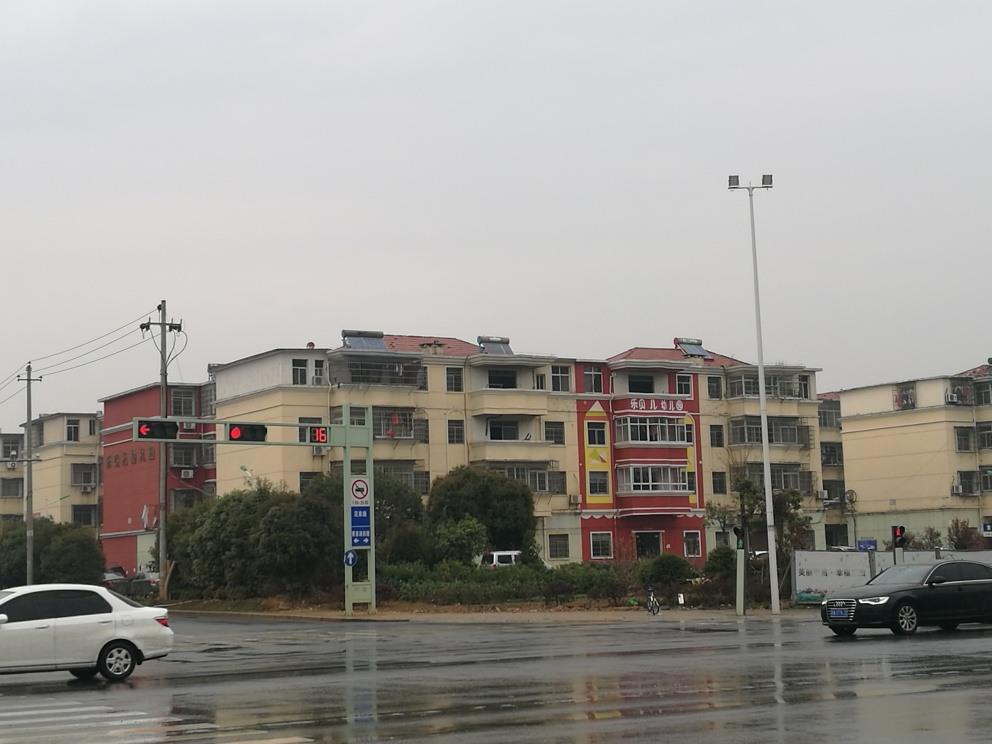What type of area does this image depict, urban or rural, and can you detail some features that support your assessment? The image depicts an urban area, as evidenced by the presence of multiple-storied buildings, paved roads, street signage, traffic lights, and a designated pedestrian crossing zone. The infrastructure such as light poles, the layout of the buildings, and the presence of vehicles all point towards an urban setting, likely on the outskirts of a city where buildings have modest height and design. 